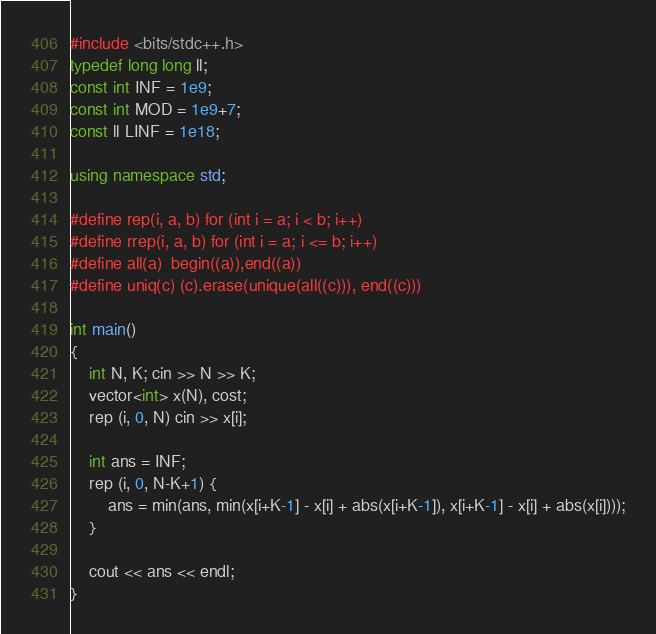<code> <loc_0><loc_0><loc_500><loc_500><_C++_>#include <bits/stdc++.h>
typedef long long ll;
const int INF = 1e9;
const int MOD = 1e9+7;
const ll LINF = 1e18;

using namespace std;

#define rep(i, a, b) for (int i = a; i < b; i++)
#define rrep(i, a, b) for (int i = a; i <= b; i++)
#define all(a)  begin((a)),end((a))
#define uniq(c) (c).erase(unique(all((c))), end((c)))

int main()
{
    int N, K; cin >> N >> K;
    vector<int> x(N), cost;
    rep (i, 0, N) cin >> x[i];

    int ans = INF;
    rep (i, 0, N-K+1) {
        ans = min(ans, min(x[i+K-1] - x[i] + abs(x[i+K-1]), x[i+K-1] - x[i] + abs(x[i])));
    }

    cout << ans << endl;
}</code> 